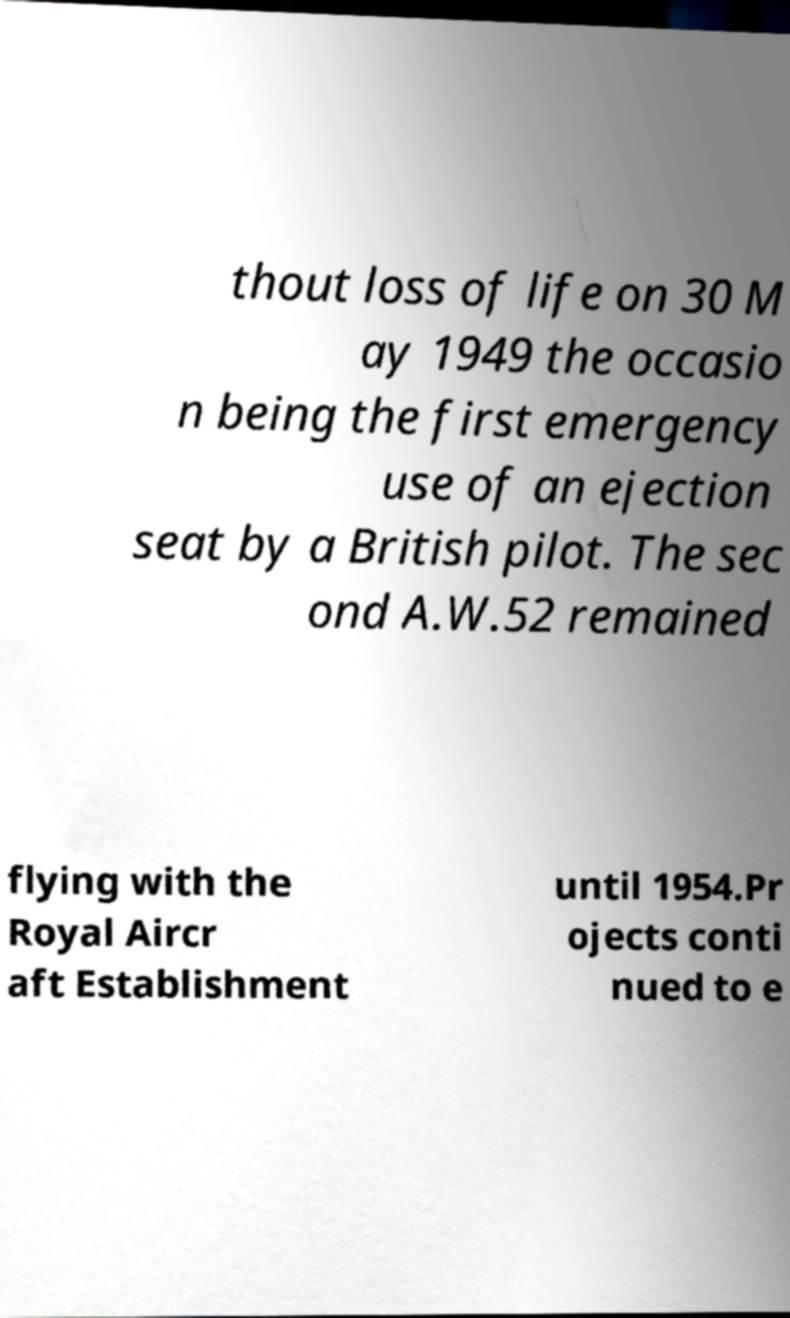Can you accurately transcribe the text from the provided image for me? thout loss of life on 30 M ay 1949 the occasio n being the first emergency use of an ejection seat by a British pilot. The sec ond A.W.52 remained flying with the Royal Aircr aft Establishment until 1954.Pr ojects conti nued to e 